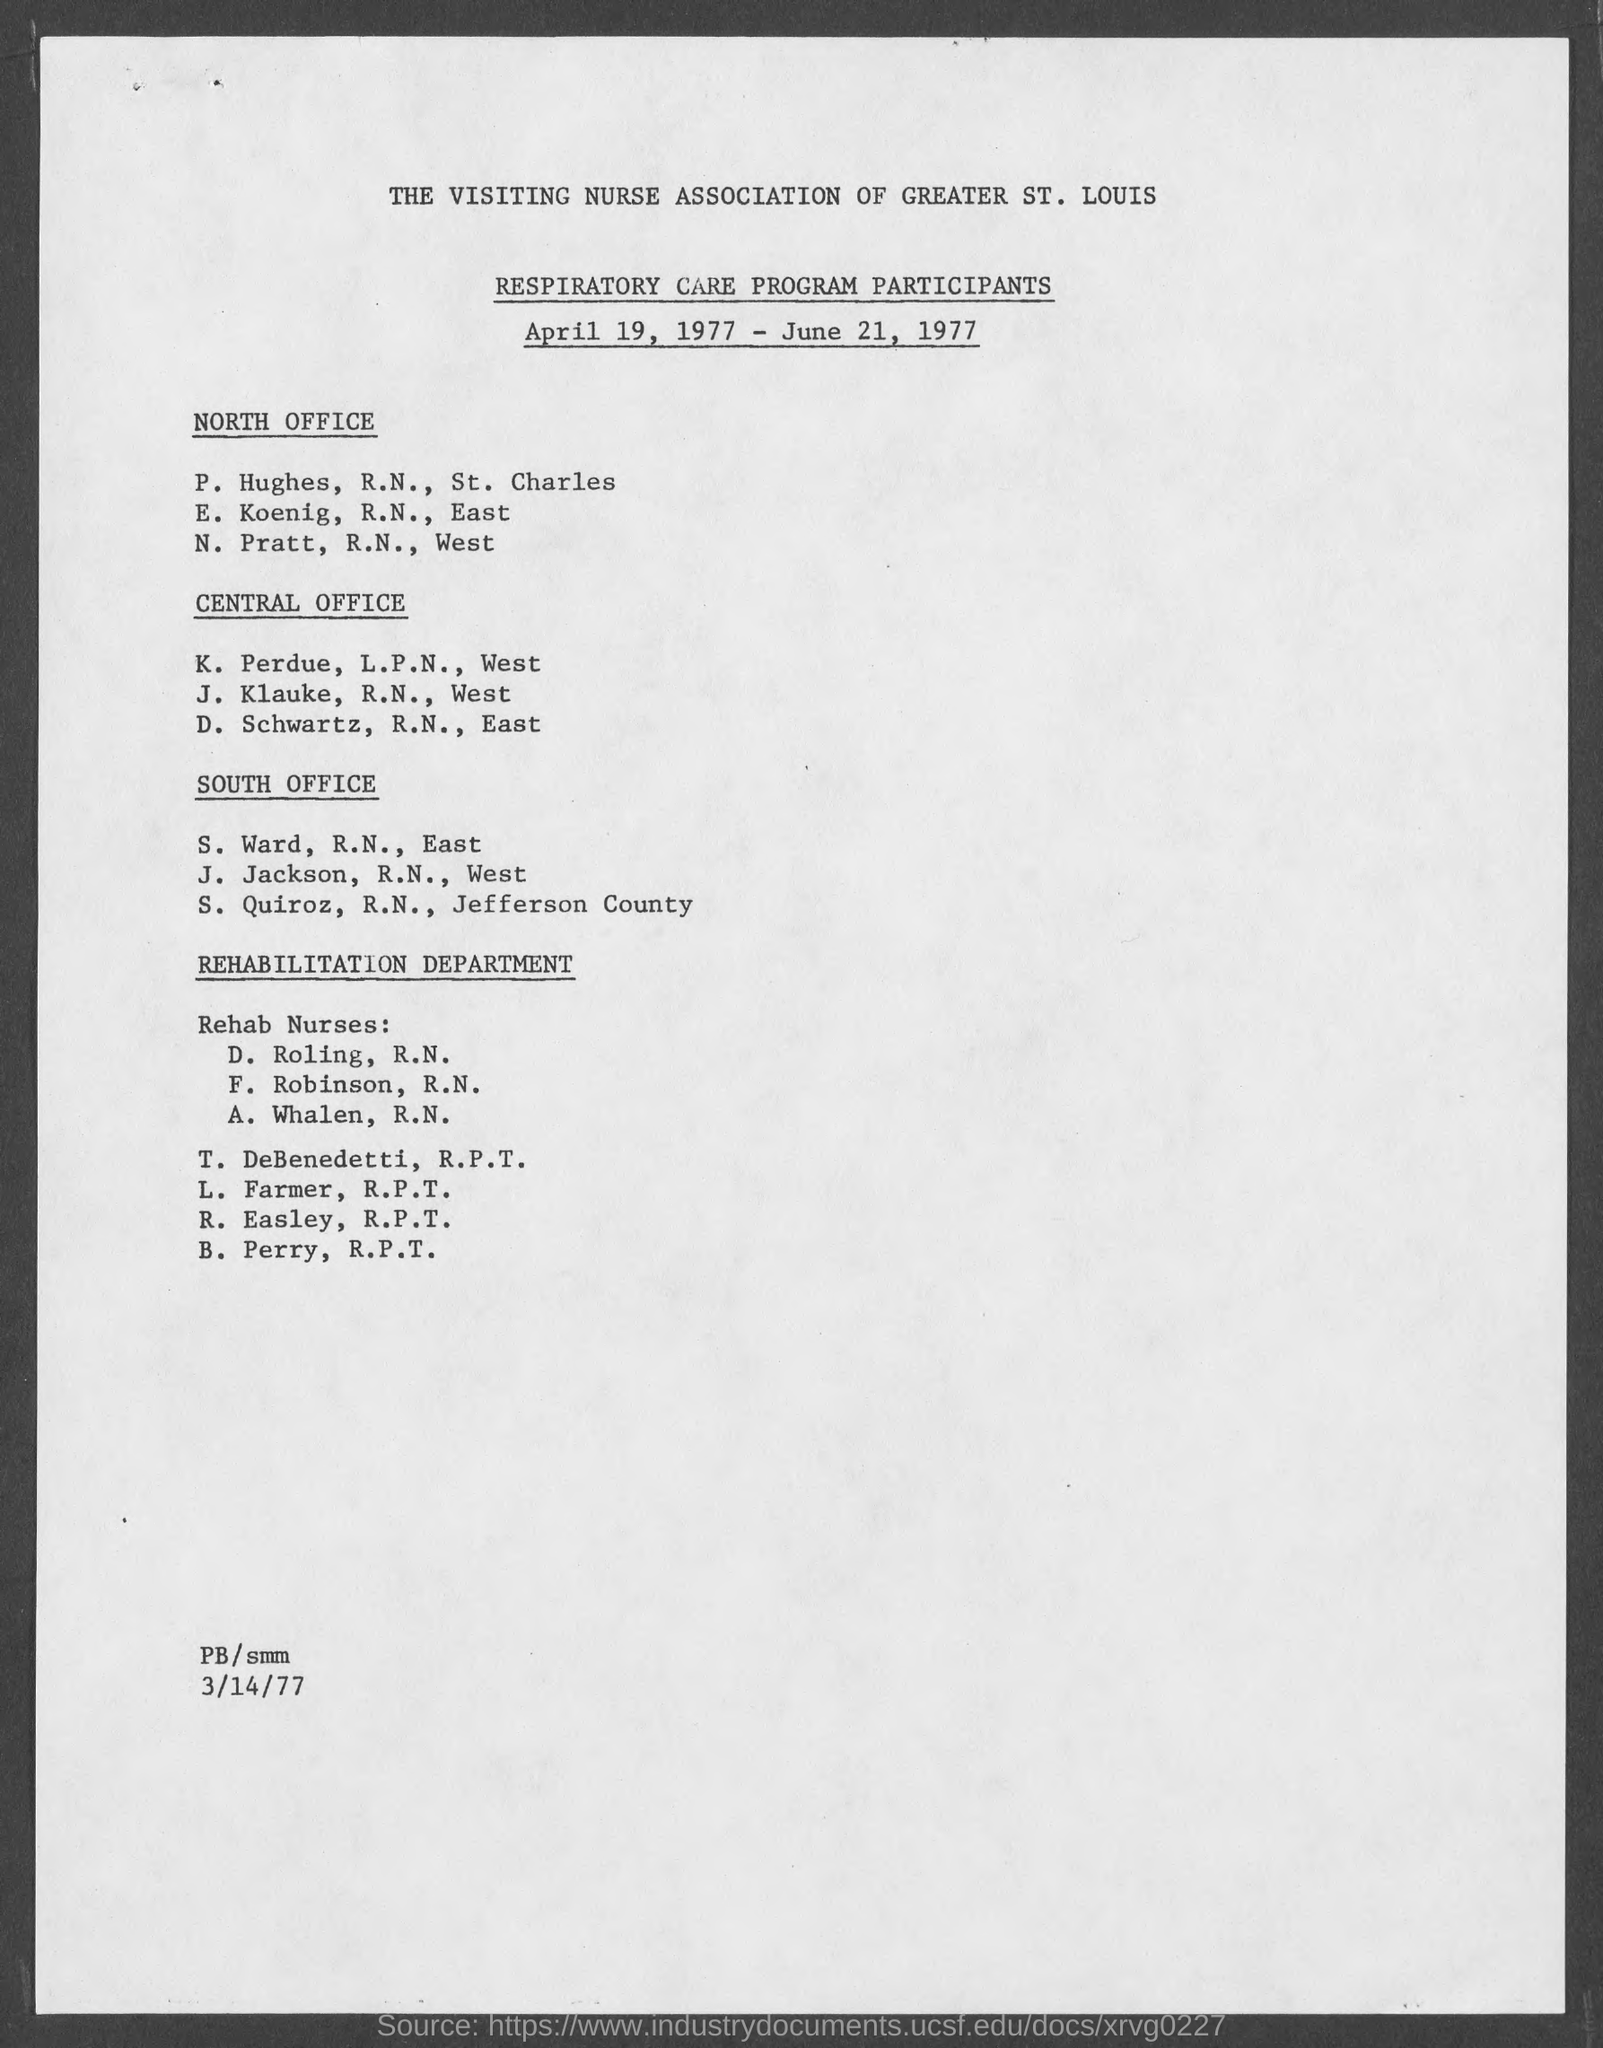Draw attention to some important aspects in this diagram. The participant details under the heading "NORTH OFFICE" are Hughes, R.N. and St. Charles. The first heading for the side provided is 'North Office'. The document provides information about the RESPIRATORY CARE PROGRAM PARTICIPANTS. The Respiratory Care Program is scheduled to begin on April 19, 1977. The Respiratory Care Program took place on April 19, 1977 and ended on June 21, 1977. 